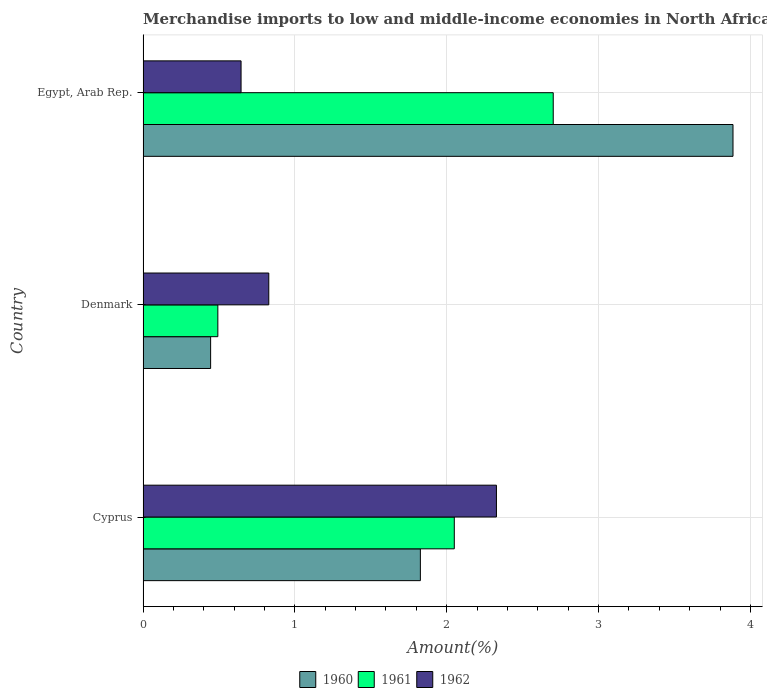How many different coloured bars are there?
Make the answer very short. 3. How many groups of bars are there?
Your response must be concise. 3. Are the number of bars per tick equal to the number of legend labels?
Offer a terse response. Yes. How many bars are there on the 3rd tick from the top?
Your answer should be very brief. 3. What is the label of the 3rd group of bars from the top?
Give a very brief answer. Cyprus. In how many cases, is the number of bars for a given country not equal to the number of legend labels?
Ensure brevity in your answer.  0. What is the percentage of amount earned from merchandise imports in 1962 in Egypt, Arab Rep.?
Offer a terse response. 0.65. Across all countries, what is the maximum percentage of amount earned from merchandise imports in 1961?
Give a very brief answer. 2.7. Across all countries, what is the minimum percentage of amount earned from merchandise imports in 1961?
Offer a terse response. 0.49. In which country was the percentage of amount earned from merchandise imports in 1961 maximum?
Give a very brief answer. Egypt, Arab Rep. What is the total percentage of amount earned from merchandise imports in 1960 in the graph?
Offer a terse response. 6.16. What is the difference between the percentage of amount earned from merchandise imports in 1962 in Denmark and that in Egypt, Arab Rep.?
Your answer should be very brief. 0.18. What is the difference between the percentage of amount earned from merchandise imports in 1960 in Cyprus and the percentage of amount earned from merchandise imports in 1962 in Egypt, Arab Rep.?
Provide a succinct answer. 1.18. What is the average percentage of amount earned from merchandise imports in 1961 per country?
Ensure brevity in your answer.  1.75. What is the difference between the percentage of amount earned from merchandise imports in 1960 and percentage of amount earned from merchandise imports in 1961 in Denmark?
Offer a terse response. -0.05. What is the ratio of the percentage of amount earned from merchandise imports in 1961 in Denmark to that in Egypt, Arab Rep.?
Your answer should be very brief. 0.18. Is the percentage of amount earned from merchandise imports in 1961 in Cyprus less than that in Denmark?
Offer a very short reply. No. Is the difference between the percentage of amount earned from merchandise imports in 1960 in Cyprus and Denmark greater than the difference between the percentage of amount earned from merchandise imports in 1961 in Cyprus and Denmark?
Ensure brevity in your answer.  No. What is the difference between the highest and the second highest percentage of amount earned from merchandise imports in 1961?
Your response must be concise. 0.65. What is the difference between the highest and the lowest percentage of amount earned from merchandise imports in 1961?
Make the answer very short. 2.21. What does the 2nd bar from the top in Cyprus represents?
Provide a short and direct response. 1961. How many bars are there?
Ensure brevity in your answer.  9. Are all the bars in the graph horizontal?
Your answer should be compact. Yes. How many countries are there in the graph?
Offer a terse response. 3. What is the difference between two consecutive major ticks on the X-axis?
Your response must be concise. 1. Does the graph contain grids?
Ensure brevity in your answer.  Yes. Where does the legend appear in the graph?
Provide a succinct answer. Bottom center. How are the legend labels stacked?
Keep it short and to the point. Horizontal. What is the title of the graph?
Give a very brief answer. Merchandise imports to low and middle-income economies in North Africa. What is the label or title of the X-axis?
Provide a succinct answer. Amount(%). What is the Amount(%) in 1960 in Cyprus?
Your response must be concise. 1.83. What is the Amount(%) of 1961 in Cyprus?
Ensure brevity in your answer.  2.05. What is the Amount(%) in 1962 in Cyprus?
Provide a succinct answer. 2.33. What is the Amount(%) of 1960 in Denmark?
Ensure brevity in your answer.  0.45. What is the Amount(%) of 1961 in Denmark?
Provide a succinct answer. 0.49. What is the Amount(%) in 1962 in Denmark?
Give a very brief answer. 0.83. What is the Amount(%) of 1960 in Egypt, Arab Rep.?
Make the answer very short. 3.89. What is the Amount(%) in 1961 in Egypt, Arab Rep.?
Your answer should be very brief. 2.7. What is the Amount(%) of 1962 in Egypt, Arab Rep.?
Provide a succinct answer. 0.65. Across all countries, what is the maximum Amount(%) of 1960?
Your response must be concise. 3.89. Across all countries, what is the maximum Amount(%) of 1961?
Your response must be concise. 2.7. Across all countries, what is the maximum Amount(%) in 1962?
Offer a very short reply. 2.33. Across all countries, what is the minimum Amount(%) of 1960?
Offer a terse response. 0.45. Across all countries, what is the minimum Amount(%) of 1961?
Your answer should be compact. 0.49. Across all countries, what is the minimum Amount(%) of 1962?
Offer a terse response. 0.65. What is the total Amount(%) in 1960 in the graph?
Provide a short and direct response. 6.16. What is the total Amount(%) in 1961 in the graph?
Your response must be concise. 5.24. What is the total Amount(%) in 1962 in the graph?
Provide a succinct answer. 3.8. What is the difference between the Amount(%) of 1960 in Cyprus and that in Denmark?
Provide a succinct answer. 1.38. What is the difference between the Amount(%) in 1961 in Cyprus and that in Denmark?
Ensure brevity in your answer.  1.56. What is the difference between the Amount(%) of 1962 in Cyprus and that in Denmark?
Your answer should be very brief. 1.5. What is the difference between the Amount(%) of 1960 in Cyprus and that in Egypt, Arab Rep.?
Provide a short and direct response. -2.06. What is the difference between the Amount(%) in 1961 in Cyprus and that in Egypt, Arab Rep.?
Offer a terse response. -0.65. What is the difference between the Amount(%) in 1962 in Cyprus and that in Egypt, Arab Rep.?
Provide a short and direct response. 1.68. What is the difference between the Amount(%) in 1960 in Denmark and that in Egypt, Arab Rep.?
Your answer should be very brief. -3.44. What is the difference between the Amount(%) in 1961 in Denmark and that in Egypt, Arab Rep.?
Ensure brevity in your answer.  -2.21. What is the difference between the Amount(%) in 1962 in Denmark and that in Egypt, Arab Rep.?
Make the answer very short. 0.18. What is the difference between the Amount(%) in 1960 in Cyprus and the Amount(%) in 1961 in Denmark?
Make the answer very short. 1.33. What is the difference between the Amount(%) of 1961 in Cyprus and the Amount(%) of 1962 in Denmark?
Keep it short and to the point. 1.22. What is the difference between the Amount(%) of 1960 in Cyprus and the Amount(%) of 1961 in Egypt, Arab Rep.?
Offer a terse response. -0.88. What is the difference between the Amount(%) of 1960 in Cyprus and the Amount(%) of 1962 in Egypt, Arab Rep.?
Offer a terse response. 1.18. What is the difference between the Amount(%) in 1961 in Cyprus and the Amount(%) in 1962 in Egypt, Arab Rep.?
Provide a succinct answer. 1.4. What is the difference between the Amount(%) of 1960 in Denmark and the Amount(%) of 1961 in Egypt, Arab Rep.?
Offer a terse response. -2.26. What is the difference between the Amount(%) in 1960 in Denmark and the Amount(%) in 1962 in Egypt, Arab Rep.?
Provide a succinct answer. -0.2. What is the difference between the Amount(%) in 1961 in Denmark and the Amount(%) in 1962 in Egypt, Arab Rep.?
Your answer should be very brief. -0.15. What is the average Amount(%) of 1960 per country?
Your answer should be very brief. 2.05. What is the average Amount(%) in 1961 per country?
Provide a short and direct response. 1.75. What is the average Amount(%) of 1962 per country?
Your answer should be very brief. 1.27. What is the difference between the Amount(%) of 1960 and Amount(%) of 1961 in Cyprus?
Provide a succinct answer. -0.22. What is the difference between the Amount(%) of 1960 and Amount(%) of 1962 in Cyprus?
Give a very brief answer. -0.5. What is the difference between the Amount(%) of 1961 and Amount(%) of 1962 in Cyprus?
Give a very brief answer. -0.28. What is the difference between the Amount(%) of 1960 and Amount(%) of 1961 in Denmark?
Offer a terse response. -0.05. What is the difference between the Amount(%) in 1960 and Amount(%) in 1962 in Denmark?
Offer a very short reply. -0.38. What is the difference between the Amount(%) in 1961 and Amount(%) in 1962 in Denmark?
Offer a very short reply. -0.34. What is the difference between the Amount(%) of 1960 and Amount(%) of 1961 in Egypt, Arab Rep.?
Give a very brief answer. 1.18. What is the difference between the Amount(%) in 1960 and Amount(%) in 1962 in Egypt, Arab Rep.?
Keep it short and to the point. 3.24. What is the difference between the Amount(%) of 1961 and Amount(%) of 1962 in Egypt, Arab Rep.?
Your answer should be compact. 2.06. What is the ratio of the Amount(%) of 1960 in Cyprus to that in Denmark?
Offer a very short reply. 4.1. What is the ratio of the Amount(%) of 1961 in Cyprus to that in Denmark?
Provide a short and direct response. 4.16. What is the ratio of the Amount(%) in 1962 in Cyprus to that in Denmark?
Ensure brevity in your answer.  2.81. What is the ratio of the Amount(%) of 1960 in Cyprus to that in Egypt, Arab Rep.?
Your answer should be very brief. 0.47. What is the ratio of the Amount(%) of 1961 in Cyprus to that in Egypt, Arab Rep.?
Offer a very short reply. 0.76. What is the ratio of the Amount(%) in 1962 in Cyprus to that in Egypt, Arab Rep.?
Offer a very short reply. 3.61. What is the ratio of the Amount(%) in 1960 in Denmark to that in Egypt, Arab Rep.?
Your response must be concise. 0.11. What is the ratio of the Amount(%) of 1961 in Denmark to that in Egypt, Arab Rep.?
Your answer should be compact. 0.18. What is the ratio of the Amount(%) of 1962 in Denmark to that in Egypt, Arab Rep.?
Ensure brevity in your answer.  1.28. What is the difference between the highest and the second highest Amount(%) of 1960?
Your answer should be very brief. 2.06. What is the difference between the highest and the second highest Amount(%) in 1961?
Make the answer very short. 0.65. What is the difference between the highest and the second highest Amount(%) of 1962?
Offer a terse response. 1.5. What is the difference between the highest and the lowest Amount(%) in 1960?
Your answer should be very brief. 3.44. What is the difference between the highest and the lowest Amount(%) in 1961?
Keep it short and to the point. 2.21. What is the difference between the highest and the lowest Amount(%) in 1962?
Provide a succinct answer. 1.68. 